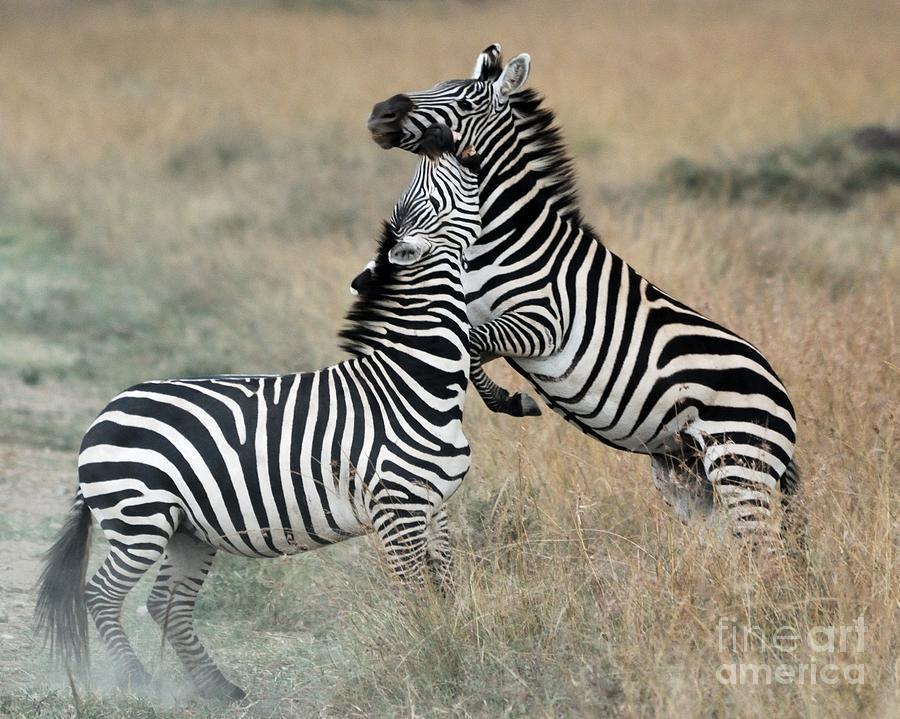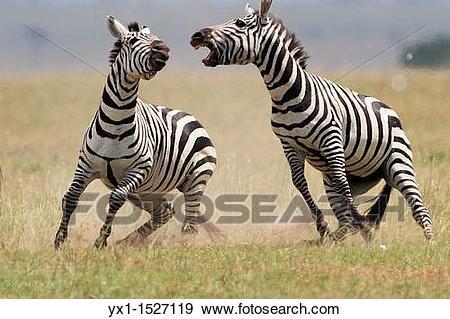The first image is the image on the left, the second image is the image on the right. Given the left and right images, does the statement "The right image contains exactly two zebras." hold true? Answer yes or no. Yes. The first image is the image on the left, the second image is the image on the right. For the images shown, is this caption "Two zebras play with each other in a field in each of the images." true? Answer yes or no. Yes. 